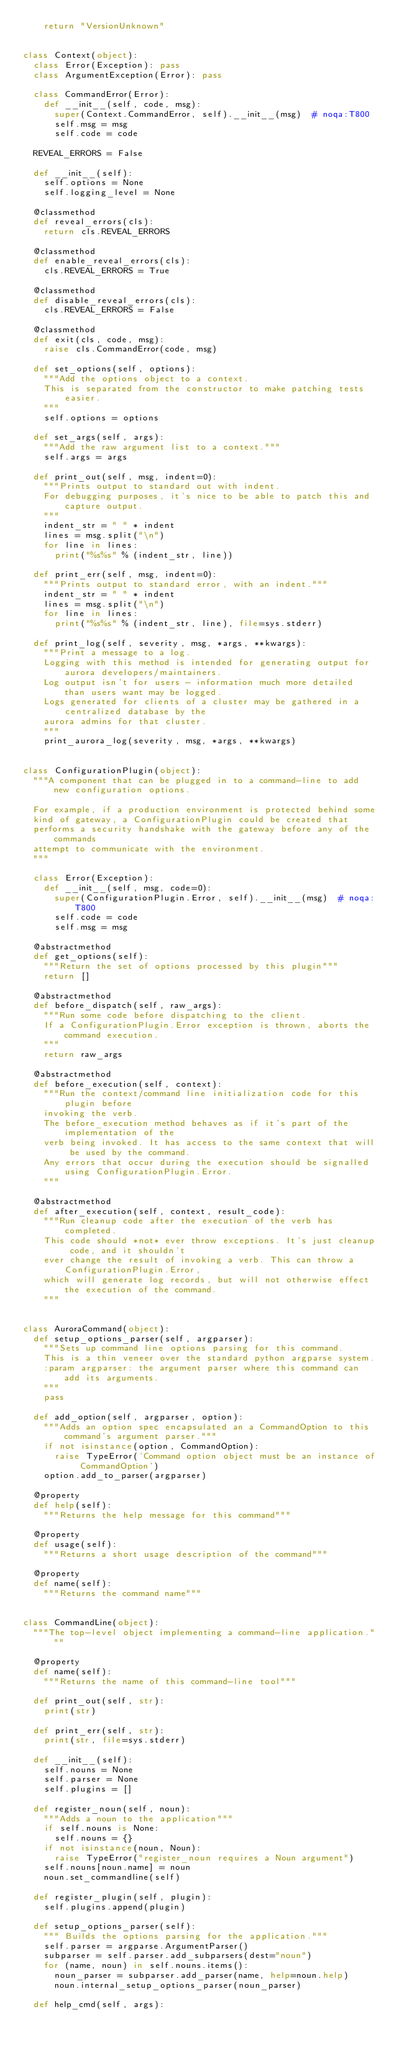Convert code to text. <code><loc_0><loc_0><loc_500><loc_500><_Python_>    return "VersionUnknown"


class Context(object):
  class Error(Exception): pass
  class ArgumentException(Error): pass

  class CommandError(Error):
    def __init__(self, code, msg):
      super(Context.CommandError, self).__init__(msg)  # noqa:T800
      self.msg = msg
      self.code = code

  REVEAL_ERRORS = False

  def __init__(self):
    self.options = None
    self.logging_level = None

  @classmethod
  def reveal_errors(cls):
    return cls.REVEAL_ERRORS

  @classmethod
  def enable_reveal_errors(cls):
    cls.REVEAL_ERRORS = True

  @classmethod
  def disable_reveal_errors(cls):
    cls.REVEAL_ERRORS = False

  @classmethod
  def exit(cls, code, msg):
    raise cls.CommandError(code, msg)

  def set_options(self, options):
    """Add the options object to a context.
    This is separated from the constructor to make patching tests easier.
    """
    self.options = options

  def set_args(self, args):
    """Add the raw argument list to a context."""
    self.args = args

  def print_out(self, msg, indent=0):
    """Prints output to standard out with indent.
    For debugging purposes, it's nice to be able to patch this and capture output.
    """
    indent_str = " " * indent
    lines = msg.split("\n")
    for line in lines:
      print("%s%s" % (indent_str, line))

  def print_err(self, msg, indent=0):
    """Prints output to standard error, with an indent."""
    indent_str = " " * indent
    lines = msg.split("\n")
    for line in lines:
      print("%s%s" % (indent_str, line), file=sys.stderr)

  def print_log(self, severity, msg, *args, **kwargs):
    """Print a message to a log.
    Logging with this method is intended for generating output for aurora developers/maintainers.
    Log output isn't for users - information much more detailed than users want may be logged.
    Logs generated for clients of a cluster may be gathered in a centralized database by the
    aurora admins for that cluster.
    """
    print_aurora_log(severity, msg, *args, **kwargs)


class ConfigurationPlugin(object):
  """A component that can be plugged in to a command-line to add new configuration options.

  For example, if a production environment is protected behind some
  kind of gateway, a ConfigurationPlugin could be created that
  performs a security handshake with the gateway before any of the commands
  attempt to communicate with the environment.
  """

  class Error(Exception):
    def __init__(self, msg, code=0):
      super(ConfigurationPlugin.Error, self).__init__(msg)  # noqa:T800
      self.code = code
      self.msg = msg

  @abstractmethod
  def get_options(self):
    """Return the set of options processed by this plugin"""
    return []

  @abstractmethod
  def before_dispatch(self, raw_args):
    """Run some code before dispatching to the client.
    If a ConfigurationPlugin.Error exception is thrown, aborts the command execution.
    """
    return raw_args

  @abstractmethod
  def before_execution(self, context):
    """Run the context/command line initialization code for this plugin before
    invoking the verb.
    The before_execution method behaves as if it's part of the implementation of the
    verb being invoked. It has access to the same context that will be used by the command.
    Any errors that occur during the execution should be signalled using ConfigurationPlugin.Error.
    """

  @abstractmethod
  def after_execution(self, context, result_code):
    """Run cleanup code after the execution of the verb has completed.
    This code should *not* ever throw exceptions. It's just cleanup code, and it shouldn't
    ever change the result of invoking a verb. This can throw a ConfigurationPlugin.Error,
    which will generate log records, but will not otherwise effect the execution of the command.
    """


class AuroraCommand(object):
  def setup_options_parser(self, argparser):
    """Sets up command line options parsing for this command.
    This is a thin veneer over the standard python argparse system.
    :param argparser: the argument parser where this command can add its arguments.
    """
    pass

  def add_option(self, argparser, option):
    """Adds an option spec encapsulated an a CommandOption to this command's argument parser."""
    if not isinstance(option, CommandOption):
      raise TypeError('Command option object must be an instance of CommandOption')
    option.add_to_parser(argparser)

  @property
  def help(self):
    """Returns the help message for this command"""

  @property
  def usage(self):
    """Returns a short usage description of the command"""

  @property
  def name(self):
    """Returns the command name"""


class CommandLine(object):
  """The top-level object implementing a command-line application."""

  @property
  def name(self):
    """Returns the name of this command-line tool"""

  def print_out(self, str):
    print(str)

  def print_err(self, str):
    print(str, file=sys.stderr)

  def __init__(self):
    self.nouns = None
    self.parser = None
    self.plugins = []

  def register_noun(self, noun):
    """Adds a noun to the application"""
    if self.nouns is None:
      self.nouns = {}
    if not isinstance(noun, Noun):
      raise TypeError("register_noun requires a Noun argument")
    self.nouns[noun.name] = noun
    noun.set_commandline(self)

  def register_plugin(self, plugin):
    self.plugins.append(plugin)

  def setup_options_parser(self):
    """ Builds the options parsing for the application."""
    self.parser = argparse.ArgumentParser()
    subparser = self.parser.add_subparsers(dest="noun")
    for (name, noun) in self.nouns.items():
      noun_parser = subparser.add_parser(name, help=noun.help)
      noun.internal_setup_options_parser(noun_parser)

  def help_cmd(self, args):</code> 